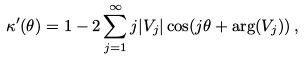Convert formula to latex. <formula><loc_0><loc_0><loc_500><loc_500>\kappa ^ { \prime } ( \theta ) = 1 - 2 \sum _ { j = 1 } ^ { \infty } j | V _ { j } | \cos ( j \theta + \arg ( V _ { j } ) ) \, ,</formula> 